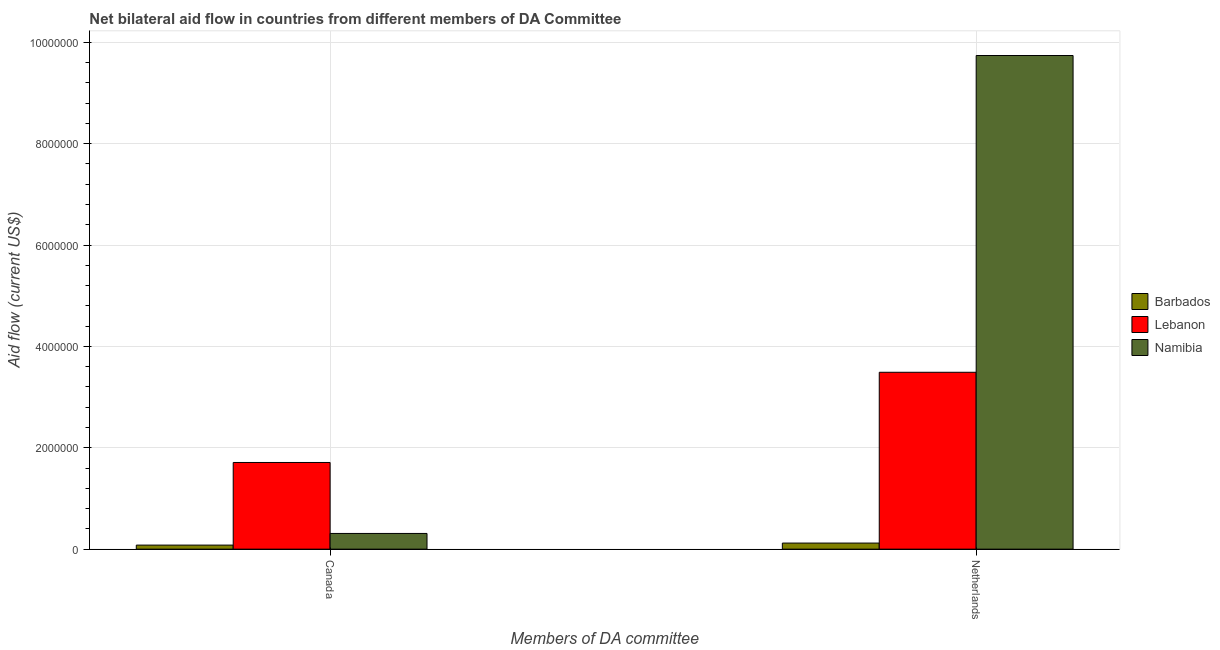How many different coloured bars are there?
Your answer should be very brief. 3. Are the number of bars per tick equal to the number of legend labels?
Ensure brevity in your answer.  Yes. Are the number of bars on each tick of the X-axis equal?
Provide a succinct answer. Yes. How many bars are there on the 2nd tick from the left?
Your answer should be compact. 3. What is the label of the 1st group of bars from the left?
Keep it short and to the point. Canada. What is the amount of aid given by canada in Barbados?
Your response must be concise. 8.00e+04. Across all countries, what is the maximum amount of aid given by netherlands?
Give a very brief answer. 9.74e+06. Across all countries, what is the minimum amount of aid given by netherlands?
Provide a short and direct response. 1.20e+05. In which country was the amount of aid given by netherlands maximum?
Offer a terse response. Namibia. In which country was the amount of aid given by netherlands minimum?
Your response must be concise. Barbados. What is the total amount of aid given by netherlands in the graph?
Offer a terse response. 1.34e+07. What is the difference between the amount of aid given by canada in Namibia and that in Lebanon?
Give a very brief answer. -1.40e+06. What is the difference between the amount of aid given by canada in Namibia and the amount of aid given by netherlands in Lebanon?
Provide a succinct answer. -3.18e+06. What is the average amount of aid given by netherlands per country?
Provide a succinct answer. 4.45e+06. What is the difference between the amount of aid given by netherlands and amount of aid given by canada in Namibia?
Your response must be concise. 9.43e+06. In how many countries, is the amount of aid given by canada greater than 6400000 US$?
Provide a short and direct response. 0. What is the ratio of the amount of aid given by canada in Barbados to that in Namibia?
Provide a succinct answer. 0.26. In how many countries, is the amount of aid given by netherlands greater than the average amount of aid given by netherlands taken over all countries?
Your answer should be compact. 1. What does the 2nd bar from the left in Netherlands represents?
Keep it short and to the point. Lebanon. What does the 3rd bar from the right in Netherlands represents?
Your answer should be compact. Barbados. How many bars are there?
Your answer should be compact. 6. Are all the bars in the graph horizontal?
Provide a succinct answer. No. Does the graph contain grids?
Keep it short and to the point. Yes. Where does the legend appear in the graph?
Your answer should be compact. Center right. How are the legend labels stacked?
Make the answer very short. Vertical. What is the title of the graph?
Make the answer very short. Net bilateral aid flow in countries from different members of DA Committee. What is the label or title of the X-axis?
Your response must be concise. Members of DA committee. What is the label or title of the Y-axis?
Your answer should be compact. Aid flow (current US$). What is the Aid flow (current US$) of Lebanon in Canada?
Offer a terse response. 1.71e+06. What is the Aid flow (current US$) of Lebanon in Netherlands?
Your response must be concise. 3.49e+06. What is the Aid flow (current US$) of Namibia in Netherlands?
Ensure brevity in your answer.  9.74e+06. Across all Members of DA committee, what is the maximum Aid flow (current US$) of Lebanon?
Your answer should be very brief. 3.49e+06. Across all Members of DA committee, what is the maximum Aid flow (current US$) of Namibia?
Your answer should be compact. 9.74e+06. Across all Members of DA committee, what is the minimum Aid flow (current US$) in Barbados?
Keep it short and to the point. 8.00e+04. Across all Members of DA committee, what is the minimum Aid flow (current US$) of Lebanon?
Ensure brevity in your answer.  1.71e+06. Across all Members of DA committee, what is the minimum Aid flow (current US$) in Namibia?
Your answer should be very brief. 3.10e+05. What is the total Aid flow (current US$) of Lebanon in the graph?
Offer a terse response. 5.20e+06. What is the total Aid flow (current US$) in Namibia in the graph?
Your answer should be very brief. 1.00e+07. What is the difference between the Aid flow (current US$) of Barbados in Canada and that in Netherlands?
Keep it short and to the point. -4.00e+04. What is the difference between the Aid flow (current US$) in Lebanon in Canada and that in Netherlands?
Provide a short and direct response. -1.78e+06. What is the difference between the Aid flow (current US$) of Namibia in Canada and that in Netherlands?
Ensure brevity in your answer.  -9.43e+06. What is the difference between the Aid flow (current US$) in Barbados in Canada and the Aid flow (current US$) in Lebanon in Netherlands?
Give a very brief answer. -3.41e+06. What is the difference between the Aid flow (current US$) of Barbados in Canada and the Aid flow (current US$) of Namibia in Netherlands?
Your response must be concise. -9.66e+06. What is the difference between the Aid flow (current US$) in Lebanon in Canada and the Aid flow (current US$) in Namibia in Netherlands?
Your answer should be compact. -8.03e+06. What is the average Aid flow (current US$) of Lebanon per Members of DA committee?
Give a very brief answer. 2.60e+06. What is the average Aid flow (current US$) in Namibia per Members of DA committee?
Give a very brief answer. 5.02e+06. What is the difference between the Aid flow (current US$) of Barbados and Aid flow (current US$) of Lebanon in Canada?
Keep it short and to the point. -1.63e+06. What is the difference between the Aid flow (current US$) of Lebanon and Aid flow (current US$) of Namibia in Canada?
Your response must be concise. 1.40e+06. What is the difference between the Aid flow (current US$) in Barbados and Aid flow (current US$) in Lebanon in Netherlands?
Offer a very short reply. -3.37e+06. What is the difference between the Aid flow (current US$) of Barbados and Aid flow (current US$) of Namibia in Netherlands?
Ensure brevity in your answer.  -9.62e+06. What is the difference between the Aid flow (current US$) in Lebanon and Aid flow (current US$) in Namibia in Netherlands?
Give a very brief answer. -6.25e+06. What is the ratio of the Aid flow (current US$) of Lebanon in Canada to that in Netherlands?
Your answer should be compact. 0.49. What is the ratio of the Aid flow (current US$) in Namibia in Canada to that in Netherlands?
Your answer should be compact. 0.03. What is the difference between the highest and the second highest Aid flow (current US$) of Barbados?
Provide a short and direct response. 4.00e+04. What is the difference between the highest and the second highest Aid flow (current US$) of Lebanon?
Provide a succinct answer. 1.78e+06. What is the difference between the highest and the second highest Aid flow (current US$) of Namibia?
Offer a very short reply. 9.43e+06. What is the difference between the highest and the lowest Aid flow (current US$) in Barbados?
Your answer should be very brief. 4.00e+04. What is the difference between the highest and the lowest Aid flow (current US$) in Lebanon?
Your answer should be compact. 1.78e+06. What is the difference between the highest and the lowest Aid flow (current US$) in Namibia?
Provide a short and direct response. 9.43e+06. 